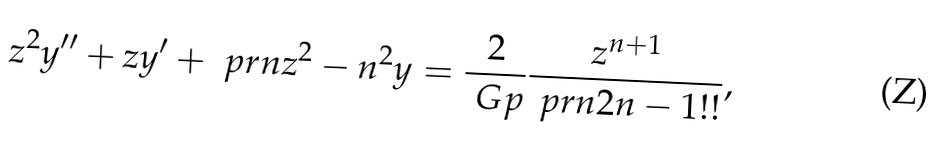<formula> <loc_0><loc_0><loc_500><loc_500>z ^ { 2 } y ^ { \prime \prime } + z y ^ { \prime } + \ p r n { z ^ { 2 } - n ^ { 2 } } y = \frac { 2 } { \ G p } \frac { z ^ { n + 1 } } { \ p r n { 2 n - 1 } ! ! } ,</formula> 